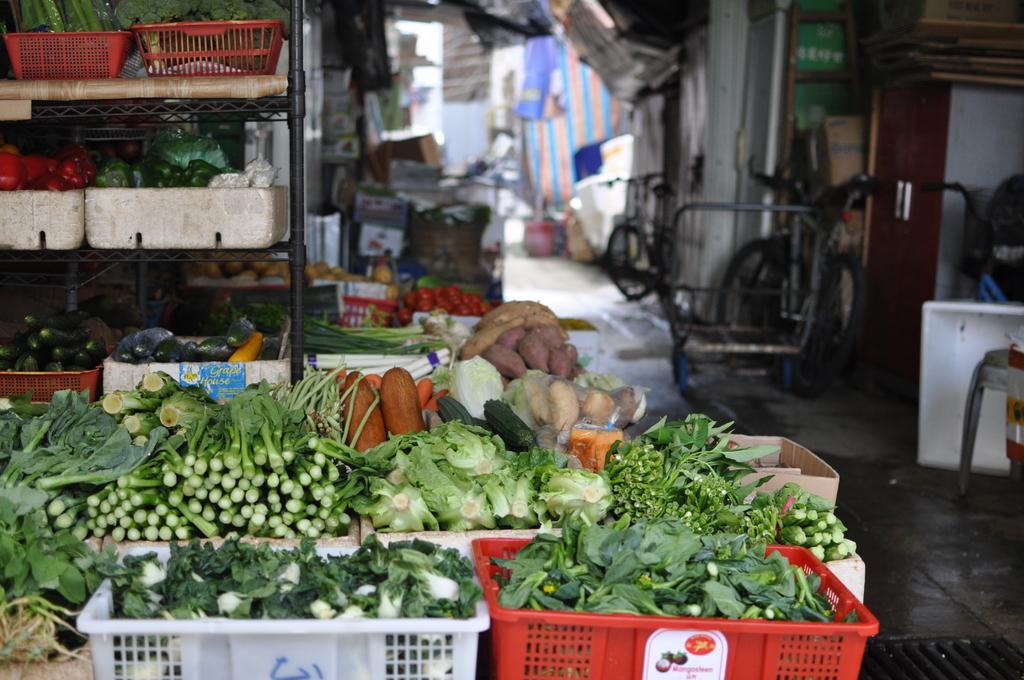Could you give a brief overview of what you see in this image? In this image we can see bicycles, blankets, cardboard cartons, vegetables arranged in the baskets, doors and floor. 